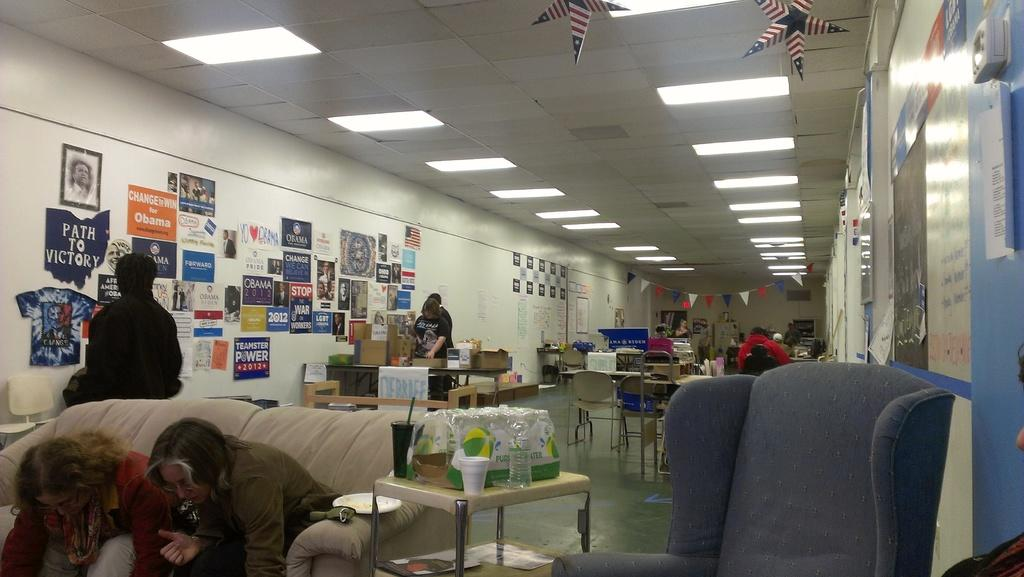What type of furniture can be seen in the room? There are chairs and tables in the room. How are the chairs and tables arranged in the room? The chairs and tables are arranged in the room. Can you describe any objects on the tables? There is a bottle on one of the tables. Are there any plants growing on the chairs in the room? A: There is no mention of plants in the provided facts, so we cannot determine if there are any plants growing on the chairs in the room. 